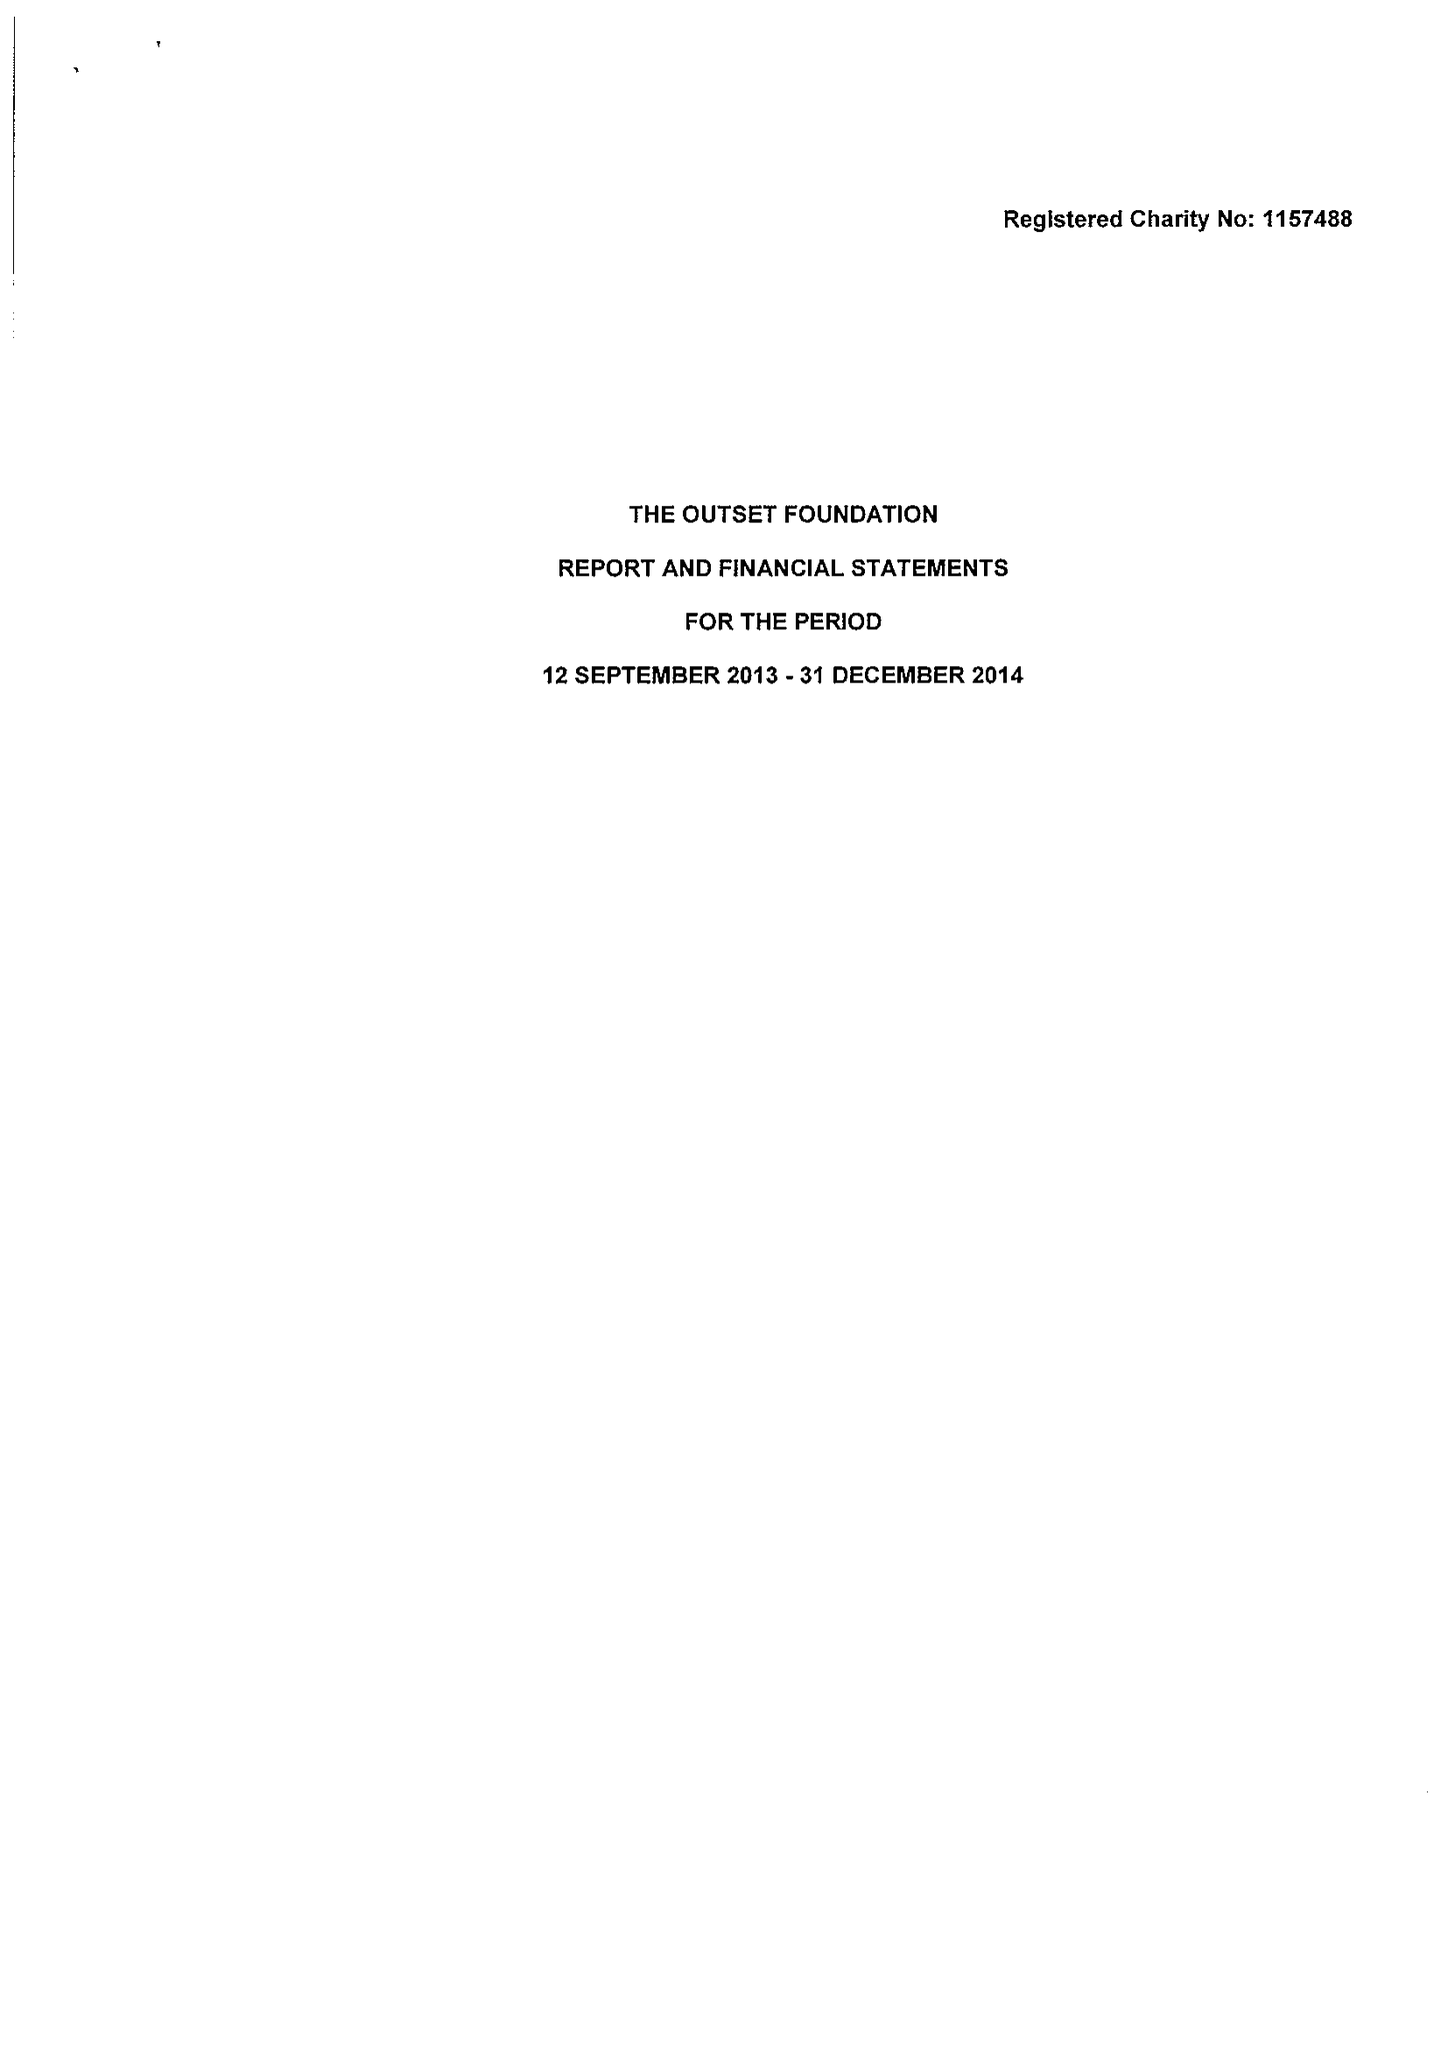What is the value for the address__street_line?
Answer the question using a single word or phrase. KIRKWOOD ROAD 